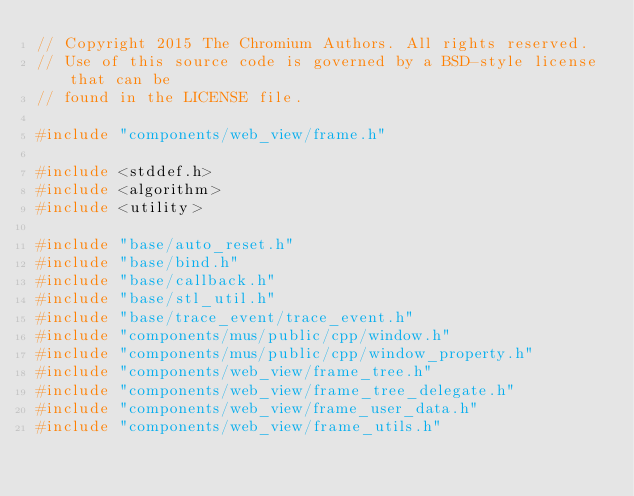<code> <loc_0><loc_0><loc_500><loc_500><_C++_>// Copyright 2015 The Chromium Authors. All rights reserved.
// Use of this source code is governed by a BSD-style license that can be
// found in the LICENSE file.

#include "components/web_view/frame.h"

#include <stddef.h>
#include <algorithm>
#include <utility>

#include "base/auto_reset.h"
#include "base/bind.h"
#include "base/callback.h"
#include "base/stl_util.h"
#include "base/trace_event/trace_event.h"
#include "components/mus/public/cpp/window.h"
#include "components/mus/public/cpp/window_property.h"
#include "components/web_view/frame_tree.h"
#include "components/web_view/frame_tree_delegate.h"
#include "components/web_view/frame_user_data.h"
#include "components/web_view/frame_utils.h"</code> 